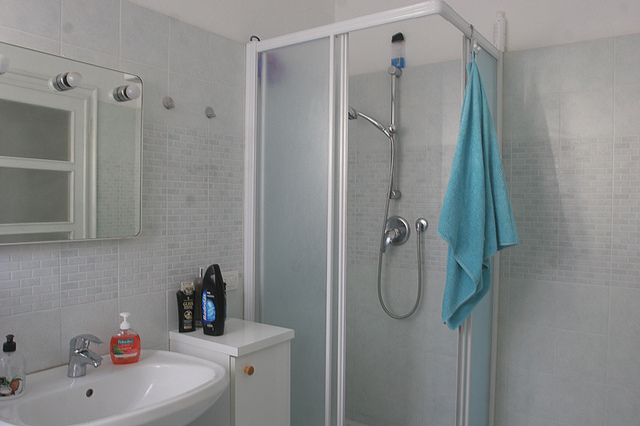What is the aqua item hanging next to the shower? The aqua item hanging next to the shower is a soft, absorbent towel, likely used for drying off after a bath or shower. 